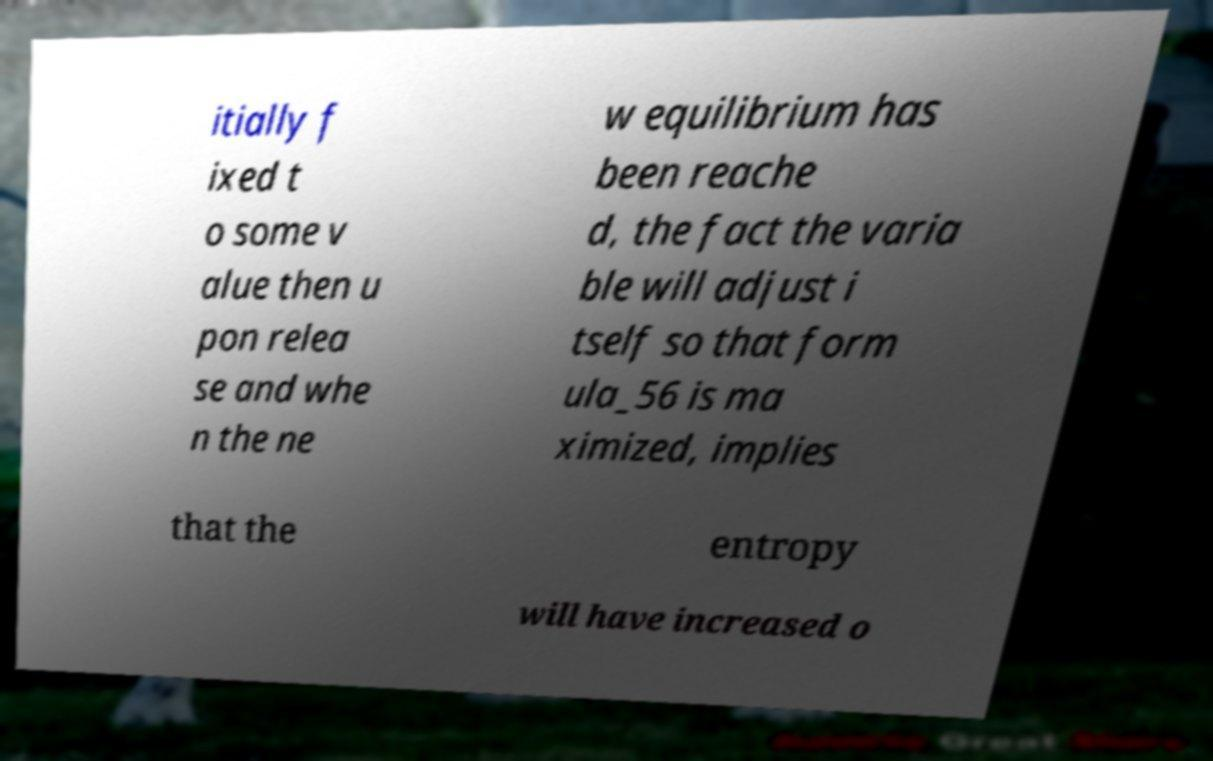There's text embedded in this image that I need extracted. Can you transcribe it verbatim? itially f ixed t o some v alue then u pon relea se and whe n the ne w equilibrium has been reache d, the fact the varia ble will adjust i tself so that form ula_56 is ma ximized, implies that the entropy will have increased o 